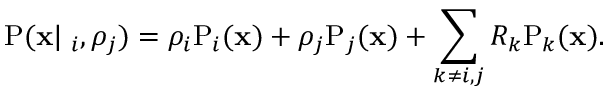Convert formula to latex. <formula><loc_0><loc_0><loc_500><loc_500>P ( \mathbf x | \mathbf \rho _ { i } , \rho _ { j } ) = \rho _ { i } \mathrm P _ { i } ( \mathbf x ) + \rho _ { j } \mathrm P _ { j } ( \mathbf x ) + \sum _ { k \neq i , j } R _ { k } \mathrm P _ { k } ( \mathbf x ) .</formula> 